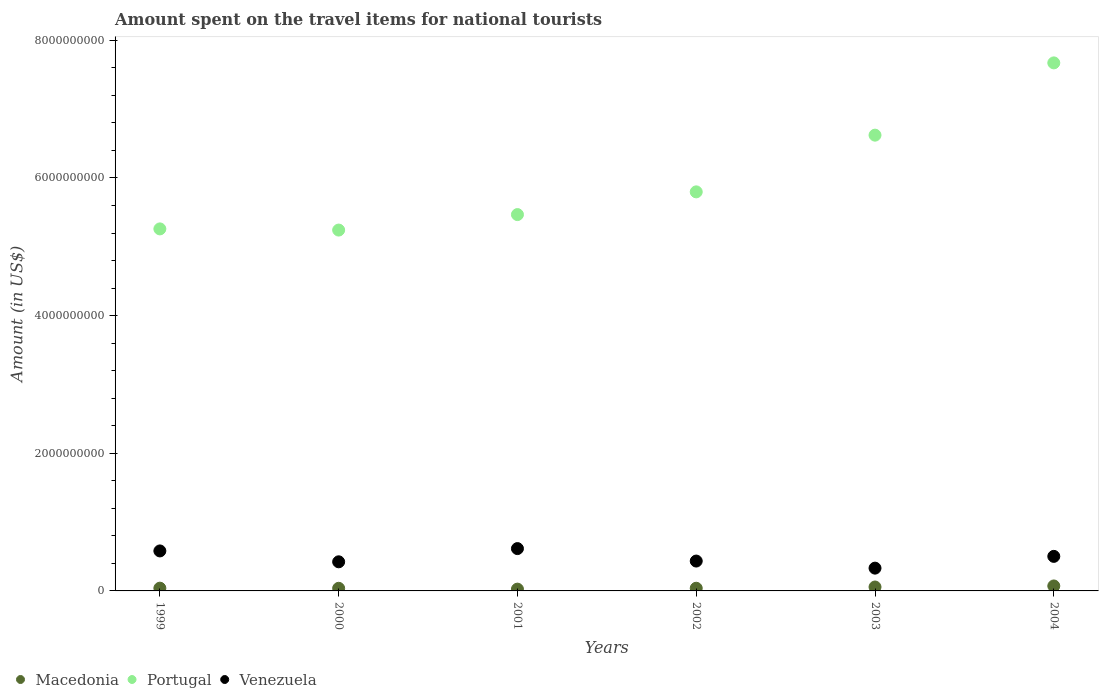How many different coloured dotlines are there?
Offer a very short reply. 3. What is the amount spent on the travel items for national tourists in Portugal in 2004?
Your answer should be very brief. 7.67e+09. Across all years, what is the maximum amount spent on the travel items for national tourists in Portugal?
Offer a terse response. 7.67e+09. Across all years, what is the minimum amount spent on the travel items for national tourists in Macedonia?
Your response must be concise. 2.60e+07. In which year was the amount spent on the travel items for national tourists in Venezuela minimum?
Your answer should be very brief. 2003. What is the total amount spent on the travel items for national tourists in Macedonia in the graph?
Make the answer very short. 2.72e+08. What is the difference between the amount spent on the travel items for national tourists in Macedonia in 2001 and that in 2004?
Give a very brief answer. -4.60e+07. What is the difference between the amount spent on the travel items for national tourists in Macedonia in 2001 and the amount spent on the travel items for national tourists in Venezuela in 2000?
Offer a very short reply. -3.97e+08. What is the average amount spent on the travel items for national tourists in Portugal per year?
Make the answer very short. 6.01e+09. In the year 2004, what is the difference between the amount spent on the travel items for national tourists in Venezuela and amount spent on the travel items for national tourists in Portugal?
Give a very brief answer. -7.17e+09. What is the ratio of the amount spent on the travel items for national tourists in Macedonia in 1999 to that in 2002?
Your answer should be very brief. 1.03. Is the difference between the amount spent on the travel items for national tourists in Venezuela in 2000 and 2004 greater than the difference between the amount spent on the travel items for national tourists in Portugal in 2000 and 2004?
Offer a terse response. Yes. What is the difference between the highest and the second highest amount spent on the travel items for national tourists in Macedonia?
Provide a succinct answer. 1.50e+07. What is the difference between the highest and the lowest amount spent on the travel items for national tourists in Portugal?
Give a very brief answer. 2.43e+09. Does the amount spent on the travel items for national tourists in Macedonia monotonically increase over the years?
Offer a very short reply. No. Is the amount spent on the travel items for national tourists in Macedonia strictly greater than the amount spent on the travel items for national tourists in Portugal over the years?
Keep it short and to the point. No. Is the amount spent on the travel items for national tourists in Venezuela strictly less than the amount spent on the travel items for national tourists in Portugal over the years?
Your response must be concise. Yes. What is the difference between two consecutive major ticks on the Y-axis?
Ensure brevity in your answer.  2.00e+09. Are the values on the major ticks of Y-axis written in scientific E-notation?
Give a very brief answer. No. Does the graph contain any zero values?
Your answer should be very brief. No. Where does the legend appear in the graph?
Your answer should be compact. Bottom left. How many legend labels are there?
Ensure brevity in your answer.  3. How are the legend labels stacked?
Ensure brevity in your answer.  Horizontal. What is the title of the graph?
Your answer should be very brief. Amount spent on the travel items for national tourists. Does "Papua New Guinea" appear as one of the legend labels in the graph?
Offer a very short reply. No. What is the label or title of the X-axis?
Your answer should be very brief. Years. What is the label or title of the Y-axis?
Your answer should be compact. Amount (in US$). What is the Amount (in US$) in Macedonia in 1999?
Provide a short and direct response. 4.00e+07. What is the Amount (in US$) of Portugal in 1999?
Keep it short and to the point. 5.26e+09. What is the Amount (in US$) of Venezuela in 1999?
Give a very brief answer. 5.81e+08. What is the Amount (in US$) of Macedonia in 2000?
Your answer should be compact. 3.80e+07. What is the Amount (in US$) in Portugal in 2000?
Ensure brevity in your answer.  5.24e+09. What is the Amount (in US$) of Venezuela in 2000?
Provide a succinct answer. 4.23e+08. What is the Amount (in US$) of Macedonia in 2001?
Your answer should be compact. 2.60e+07. What is the Amount (in US$) in Portugal in 2001?
Offer a very short reply. 5.47e+09. What is the Amount (in US$) in Venezuela in 2001?
Offer a terse response. 6.15e+08. What is the Amount (in US$) of Macedonia in 2002?
Provide a succinct answer. 3.90e+07. What is the Amount (in US$) of Portugal in 2002?
Your answer should be very brief. 5.80e+09. What is the Amount (in US$) of Venezuela in 2002?
Ensure brevity in your answer.  4.34e+08. What is the Amount (in US$) in Macedonia in 2003?
Provide a short and direct response. 5.70e+07. What is the Amount (in US$) of Portugal in 2003?
Your answer should be very brief. 6.62e+09. What is the Amount (in US$) in Venezuela in 2003?
Ensure brevity in your answer.  3.31e+08. What is the Amount (in US$) of Macedonia in 2004?
Offer a very short reply. 7.20e+07. What is the Amount (in US$) in Portugal in 2004?
Your response must be concise. 7.67e+09. What is the Amount (in US$) in Venezuela in 2004?
Give a very brief answer. 5.02e+08. Across all years, what is the maximum Amount (in US$) of Macedonia?
Offer a terse response. 7.20e+07. Across all years, what is the maximum Amount (in US$) of Portugal?
Your answer should be very brief. 7.67e+09. Across all years, what is the maximum Amount (in US$) in Venezuela?
Your response must be concise. 6.15e+08. Across all years, what is the minimum Amount (in US$) of Macedonia?
Your response must be concise. 2.60e+07. Across all years, what is the minimum Amount (in US$) of Portugal?
Provide a short and direct response. 5.24e+09. Across all years, what is the minimum Amount (in US$) in Venezuela?
Make the answer very short. 3.31e+08. What is the total Amount (in US$) of Macedonia in the graph?
Your response must be concise. 2.72e+08. What is the total Amount (in US$) of Portugal in the graph?
Provide a short and direct response. 3.61e+1. What is the total Amount (in US$) of Venezuela in the graph?
Offer a very short reply. 2.89e+09. What is the difference between the Amount (in US$) of Macedonia in 1999 and that in 2000?
Your answer should be compact. 2.00e+06. What is the difference between the Amount (in US$) of Portugal in 1999 and that in 2000?
Give a very brief answer. 1.70e+07. What is the difference between the Amount (in US$) of Venezuela in 1999 and that in 2000?
Ensure brevity in your answer.  1.58e+08. What is the difference between the Amount (in US$) in Macedonia in 1999 and that in 2001?
Make the answer very short. 1.40e+07. What is the difference between the Amount (in US$) in Portugal in 1999 and that in 2001?
Give a very brief answer. -2.08e+08. What is the difference between the Amount (in US$) of Venezuela in 1999 and that in 2001?
Your answer should be very brief. -3.40e+07. What is the difference between the Amount (in US$) in Macedonia in 1999 and that in 2002?
Provide a succinct answer. 1.00e+06. What is the difference between the Amount (in US$) in Portugal in 1999 and that in 2002?
Give a very brief answer. -5.38e+08. What is the difference between the Amount (in US$) of Venezuela in 1999 and that in 2002?
Ensure brevity in your answer.  1.47e+08. What is the difference between the Amount (in US$) in Macedonia in 1999 and that in 2003?
Make the answer very short. -1.70e+07. What is the difference between the Amount (in US$) of Portugal in 1999 and that in 2003?
Provide a short and direct response. -1.36e+09. What is the difference between the Amount (in US$) in Venezuela in 1999 and that in 2003?
Your response must be concise. 2.50e+08. What is the difference between the Amount (in US$) of Macedonia in 1999 and that in 2004?
Provide a succinct answer. -3.20e+07. What is the difference between the Amount (in US$) in Portugal in 1999 and that in 2004?
Provide a succinct answer. -2.41e+09. What is the difference between the Amount (in US$) of Venezuela in 1999 and that in 2004?
Make the answer very short. 7.90e+07. What is the difference between the Amount (in US$) in Portugal in 2000 and that in 2001?
Keep it short and to the point. -2.25e+08. What is the difference between the Amount (in US$) in Venezuela in 2000 and that in 2001?
Give a very brief answer. -1.92e+08. What is the difference between the Amount (in US$) in Macedonia in 2000 and that in 2002?
Offer a terse response. -1.00e+06. What is the difference between the Amount (in US$) in Portugal in 2000 and that in 2002?
Provide a succinct answer. -5.55e+08. What is the difference between the Amount (in US$) in Venezuela in 2000 and that in 2002?
Offer a very short reply. -1.10e+07. What is the difference between the Amount (in US$) of Macedonia in 2000 and that in 2003?
Make the answer very short. -1.90e+07. What is the difference between the Amount (in US$) in Portugal in 2000 and that in 2003?
Offer a very short reply. -1.38e+09. What is the difference between the Amount (in US$) of Venezuela in 2000 and that in 2003?
Offer a terse response. 9.20e+07. What is the difference between the Amount (in US$) in Macedonia in 2000 and that in 2004?
Your answer should be very brief. -3.40e+07. What is the difference between the Amount (in US$) in Portugal in 2000 and that in 2004?
Your answer should be compact. -2.43e+09. What is the difference between the Amount (in US$) of Venezuela in 2000 and that in 2004?
Your answer should be compact. -7.90e+07. What is the difference between the Amount (in US$) of Macedonia in 2001 and that in 2002?
Make the answer very short. -1.30e+07. What is the difference between the Amount (in US$) of Portugal in 2001 and that in 2002?
Make the answer very short. -3.30e+08. What is the difference between the Amount (in US$) in Venezuela in 2001 and that in 2002?
Offer a terse response. 1.81e+08. What is the difference between the Amount (in US$) of Macedonia in 2001 and that in 2003?
Ensure brevity in your answer.  -3.10e+07. What is the difference between the Amount (in US$) in Portugal in 2001 and that in 2003?
Provide a succinct answer. -1.15e+09. What is the difference between the Amount (in US$) in Venezuela in 2001 and that in 2003?
Your answer should be very brief. 2.84e+08. What is the difference between the Amount (in US$) in Macedonia in 2001 and that in 2004?
Make the answer very short. -4.60e+07. What is the difference between the Amount (in US$) in Portugal in 2001 and that in 2004?
Offer a very short reply. -2.20e+09. What is the difference between the Amount (in US$) in Venezuela in 2001 and that in 2004?
Your answer should be compact. 1.13e+08. What is the difference between the Amount (in US$) of Macedonia in 2002 and that in 2003?
Your answer should be compact. -1.80e+07. What is the difference between the Amount (in US$) in Portugal in 2002 and that in 2003?
Make the answer very short. -8.24e+08. What is the difference between the Amount (in US$) in Venezuela in 2002 and that in 2003?
Give a very brief answer. 1.03e+08. What is the difference between the Amount (in US$) of Macedonia in 2002 and that in 2004?
Offer a very short reply. -3.30e+07. What is the difference between the Amount (in US$) in Portugal in 2002 and that in 2004?
Keep it short and to the point. -1.87e+09. What is the difference between the Amount (in US$) in Venezuela in 2002 and that in 2004?
Your answer should be compact. -6.80e+07. What is the difference between the Amount (in US$) of Macedonia in 2003 and that in 2004?
Provide a succinct answer. -1.50e+07. What is the difference between the Amount (in US$) in Portugal in 2003 and that in 2004?
Offer a terse response. -1.05e+09. What is the difference between the Amount (in US$) of Venezuela in 2003 and that in 2004?
Your answer should be very brief. -1.71e+08. What is the difference between the Amount (in US$) in Macedonia in 1999 and the Amount (in US$) in Portugal in 2000?
Provide a succinct answer. -5.20e+09. What is the difference between the Amount (in US$) in Macedonia in 1999 and the Amount (in US$) in Venezuela in 2000?
Make the answer very short. -3.83e+08. What is the difference between the Amount (in US$) in Portugal in 1999 and the Amount (in US$) in Venezuela in 2000?
Keep it short and to the point. 4.84e+09. What is the difference between the Amount (in US$) in Macedonia in 1999 and the Amount (in US$) in Portugal in 2001?
Your answer should be very brief. -5.43e+09. What is the difference between the Amount (in US$) in Macedonia in 1999 and the Amount (in US$) in Venezuela in 2001?
Offer a terse response. -5.75e+08. What is the difference between the Amount (in US$) of Portugal in 1999 and the Amount (in US$) of Venezuela in 2001?
Ensure brevity in your answer.  4.64e+09. What is the difference between the Amount (in US$) of Macedonia in 1999 and the Amount (in US$) of Portugal in 2002?
Make the answer very short. -5.76e+09. What is the difference between the Amount (in US$) of Macedonia in 1999 and the Amount (in US$) of Venezuela in 2002?
Provide a short and direct response. -3.94e+08. What is the difference between the Amount (in US$) in Portugal in 1999 and the Amount (in US$) in Venezuela in 2002?
Give a very brief answer. 4.83e+09. What is the difference between the Amount (in US$) of Macedonia in 1999 and the Amount (in US$) of Portugal in 2003?
Offer a terse response. -6.58e+09. What is the difference between the Amount (in US$) of Macedonia in 1999 and the Amount (in US$) of Venezuela in 2003?
Ensure brevity in your answer.  -2.91e+08. What is the difference between the Amount (in US$) of Portugal in 1999 and the Amount (in US$) of Venezuela in 2003?
Your answer should be very brief. 4.93e+09. What is the difference between the Amount (in US$) of Macedonia in 1999 and the Amount (in US$) of Portugal in 2004?
Keep it short and to the point. -7.63e+09. What is the difference between the Amount (in US$) of Macedonia in 1999 and the Amount (in US$) of Venezuela in 2004?
Make the answer very short. -4.62e+08. What is the difference between the Amount (in US$) in Portugal in 1999 and the Amount (in US$) in Venezuela in 2004?
Offer a very short reply. 4.76e+09. What is the difference between the Amount (in US$) of Macedonia in 2000 and the Amount (in US$) of Portugal in 2001?
Offer a very short reply. -5.43e+09. What is the difference between the Amount (in US$) of Macedonia in 2000 and the Amount (in US$) of Venezuela in 2001?
Your answer should be compact. -5.77e+08. What is the difference between the Amount (in US$) in Portugal in 2000 and the Amount (in US$) in Venezuela in 2001?
Offer a very short reply. 4.63e+09. What is the difference between the Amount (in US$) of Macedonia in 2000 and the Amount (in US$) of Portugal in 2002?
Offer a very short reply. -5.76e+09. What is the difference between the Amount (in US$) of Macedonia in 2000 and the Amount (in US$) of Venezuela in 2002?
Ensure brevity in your answer.  -3.96e+08. What is the difference between the Amount (in US$) in Portugal in 2000 and the Amount (in US$) in Venezuela in 2002?
Make the answer very short. 4.81e+09. What is the difference between the Amount (in US$) of Macedonia in 2000 and the Amount (in US$) of Portugal in 2003?
Provide a succinct answer. -6.58e+09. What is the difference between the Amount (in US$) in Macedonia in 2000 and the Amount (in US$) in Venezuela in 2003?
Provide a succinct answer. -2.93e+08. What is the difference between the Amount (in US$) of Portugal in 2000 and the Amount (in US$) of Venezuela in 2003?
Give a very brief answer. 4.91e+09. What is the difference between the Amount (in US$) of Macedonia in 2000 and the Amount (in US$) of Portugal in 2004?
Offer a very short reply. -7.63e+09. What is the difference between the Amount (in US$) in Macedonia in 2000 and the Amount (in US$) in Venezuela in 2004?
Make the answer very short. -4.64e+08. What is the difference between the Amount (in US$) in Portugal in 2000 and the Amount (in US$) in Venezuela in 2004?
Provide a short and direct response. 4.74e+09. What is the difference between the Amount (in US$) of Macedonia in 2001 and the Amount (in US$) of Portugal in 2002?
Keep it short and to the point. -5.77e+09. What is the difference between the Amount (in US$) in Macedonia in 2001 and the Amount (in US$) in Venezuela in 2002?
Ensure brevity in your answer.  -4.08e+08. What is the difference between the Amount (in US$) of Portugal in 2001 and the Amount (in US$) of Venezuela in 2002?
Your response must be concise. 5.03e+09. What is the difference between the Amount (in US$) in Macedonia in 2001 and the Amount (in US$) in Portugal in 2003?
Keep it short and to the point. -6.60e+09. What is the difference between the Amount (in US$) of Macedonia in 2001 and the Amount (in US$) of Venezuela in 2003?
Offer a terse response. -3.05e+08. What is the difference between the Amount (in US$) in Portugal in 2001 and the Amount (in US$) in Venezuela in 2003?
Your response must be concise. 5.14e+09. What is the difference between the Amount (in US$) of Macedonia in 2001 and the Amount (in US$) of Portugal in 2004?
Keep it short and to the point. -7.65e+09. What is the difference between the Amount (in US$) of Macedonia in 2001 and the Amount (in US$) of Venezuela in 2004?
Make the answer very short. -4.76e+08. What is the difference between the Amount (in US$) in Portugal in 2001 and the Amount (in US$) in Venezuela in 2004?
Keep it short and to the point. 4.97e+09. What is the difference between the Amount (in US$) of Macedonia in 2002 and the Amount (in US$) of Portugal in 2003?
Offer a very short reply. -6.58e+09. What is the difference between the Amount (in US$) in Macedonia in 2002 and the Amount (in US$) in Venezuela in 2003?
Provide a short and direct response. -2.92e+08. What is the difference between the Amount (in US$) in Portugal in 2002 and the Amount (in US$) in Venezuela in 2003?
Provide a succinct answer. 5.47e+09. What is the difference between the Amount (in US$) in Macedonia in 2002 and the Amount (in US$) in Portugal in 2004?
Your answer should be very brief. -7.63e+09. What is the difference between the Amount (in US$) in Macedonia in 2002 and the Amount (in US$) in Venezuela in 2004?
Make the answer very short. -4.63e+08. What is the difference between the Amount (in US$) in Portugal in 2002 and the Amount (in US$) in Venezuela in 2004?
Provide a short and direct response. 5.30e+09. What is the difference between the Amount (in US$) of Macedonia in 2003 and the Amount (in US$) of Portugal in 2004?
Provide a succinct answer. -7.62e+09. What is the difference between the Amount (in US$) in Macedonia in 2003 and the Amount (in US$) in Venezuela in 2004?
Keep it short and to the point. -4.45e+08. What is the difference between the Amount (in US$) of Portugal in 2003 and the Amount (in US$) of Venezuela in 2004?
Keep it short and to the point. 6.12e+09. What is the average Amount (in US$) in Macedonia per year?
Make the answer very short. 4.53e+07. What is the average Amount (in US$) of Portugal per year?
Ensure brevity in your answer.  6.01e+09. What is the average Amount (in US$) of Venezuela per year?
Provide a short and direct response. 4.81e+08. In the year 1999, what is the difference between the Amount (in US$) in Macedonia and Amount (in US$) in Portugal?
Keep it short and to the point. -5.22e+09. In the year 1999, what is the difference between the Amount (in US$) of Macedonia and Amount (in US$) of Venezuela?
Your answer should be compact. -5.41e+08. In the year 1999, what is the difference between the Amount (in US$) of Portugal and Amount (in US$) of Venezuela?
Provide a succinct answer. 4.68e+09. In the year 2000, what is the difference between the Amount (in US$) of Macedonia and Amount (in US$) of Portugal?
Your answer should be very brief. -5.20e+09. In the year 2000, what is the difference between the Amount (in US$) of Macedonia and Amount (in US$) of Venezuela?
Offer a very short reply. -3.85e+08. In the year 2000, what is the difference between the Amount (in US$) in Portugal and Amount (in US$) in Venezuela?
Provide a succinct answer. 4.82e+09. In the year 2001, what is the difference between the Amount (in US$) in Macedonia and Amount (in US$) in Portugal?
Make the answer very short. -5.44e+09. In the year 2001, what is the difference between the Amount (in US$) in Macedonia and Amount (in US$) in Venezuela?
Your answer should be compact. -5.89e+08. In the year 2001, what is the difference between the Amount (in US$) in Portugal and Amount (in US$) in Venezuela?
Your answer should be compact. 4.85e+09. In the year 2002, what is the difference between the Amount (in US$) of Macedonia and Amount (in US$) of Portugal?
Offer a very short reply. -5.76e+09. In the year 2002, what is the difference between the Amount (in US$) of Macedonia and Amount (in US$) of Venezuela?
Your answer should be compact. -3.95e+08. In the year 2002, what is the difference between the Amount (in US$) in Portugal and Amount (in US$) in Venezuela?
Provide a short and direct response. 5.36e+09. In the year 2003, what is the difference between the Amount (in US$) of Macedonia and Amount (in US$) of Portugal?
Ensure brevity in your answer.  -6.56e+09. In the year 2003, what is the difference between the Amount (in US$) of Macedonia and Amount (in US$) of Venezuela?
Offer a very short reply. -2.74e+08. In the year 2003, what is the difference between the Amount (in US$) in Portugal and Amount (in US$) in Venezuela?
Give a very brief answer. 6.29e+09. In the year 2004, what is the difference between the Amount (in US$) in Macedonia and Amount (in US$) in Portugal?
Your answer should be very brief. -7.60e+09. In the year 2004, what is the difference between the Amount (in US$) of Macedonia and Amount (in US$) of Venezuela?
Offer a terse response. -4.30e+08. In the year 2004, what is the difference between the Amount (in US$) of Portugal and Amount (in US$) of Venezuela?
Provide a succinct answer. 7.17e+09. What is the ratio of the Amount (in US$) of Macedonia in 1999 to that in 2000?
Offer a terse response. 1.05. What is the ratio of the Amount (in US$) of Portugal in 1999 to that in 2000?
Your answer should be compact. 1. What is the ratio of the Amount (in US$) of Venezuela in 1999 to that in 2000?
Ensure brevity in your answer.  1.37. What is the ratio of the Amount (in US$) in Macedonia in 1999 to that in 2001?
Offer a terse response. 1.54. What is the ratio of the Amount (in US$) of Portugal in 1999 to that in 2001?
Offer a terse response. 0.96. What is the ratio of the Amount (in US$) of Venezuela in 1999 to that in 2001?
Your answer should be very brief. 0.94. What is the ratio of the Amount (in US$) in Macedonia in 1999 to that in 2002?
Keep it short and to the point. 1.03. What is the ratio of the Amount (in US$) of Portugal in 1999 to that in 2002?
Your answer should be very brief. 0.91. What is the ratio of the Amount (in US$) in Venezuela in 1999 to that in 2002?
Keep it short and to the point. 1.34. What is the ratio of the Amount (in US$) of Macedonia in 1999 to that in 2003?
Ensure brevity in your answer.  0.7. What is the ratio of the Amount (in US$) of Portugal in 1999 to that in 2003?
Your response must be concise. 0.79. What is the ratio of the Amount (in US$) of Venezuela in 1999 to that in 2003?
Offer a very short reply. 1.76. What is the ratio of the Amount (in US$) in Macedonia in 1999 to that in 2004?
Your response must be concise. 0.56. What is the ratio of the Amount (in US$) of Portugal in 1999 to that in 2004?
Give a very brief answer. 0.69. What is the ratio of the Amount (in US$) of Venezuela in 1999 to that in 2004?
Your response must be concise. 1.16. What is the ratio of the Amount (in US$) in Macedonia in 2000 to that in 2001?
Provide a short and direct response. 1.46. What is the ratio of the Amount (in US$) of Portugal in 2000 to that in 2001?
Offer a terse response. 0.96. What is the ratio of the Amount (in US$) in Venezuela in 2000 to that in 2001?
Ensure brevity in your answer.  0.69. What is the ratio of the Amount (in US$) of Macedonia in 2000 to that in 2002?
Ensure brevity in your answer.  0.97. What is the ratio of the Amount (in US$) in Portugal in 2000 to that in 2002?
Provide a short and direct response. 0.9. What is the ratio of the Amount (in US$) of Venezuela in 2000 to that in 2002?
Your answer should be very brief. 0.97. What is the ratio of the Amount (in US$) of Macedonia in 2000 to that in 2003?
Offer a terse response. 0.67. What is the ratio of the Amount (in US$) of Portugal in 2000 to that in 2003?
Keep it short and to the point. 0.79. What is the ratio of the Amount (in US$) of Venezuela in 2000 to that in 2003?
Offer a very short reply. 1.28. What is the ratio of the Amount (in US$) in Macedonia in 2000 to that in 2004?
Ensure brevity in your answer.  0.53. What is the ratio of the Amount (in US$) of Portugal in 2000 to that in 2004?
Give a very brief answer. 0.68. What is the ratio of the Amount (in US$) of Venezuela in 2000 to that in 2004?
Your response must be concise. 0.84. What is the ratio of the Amount (in US$) in Portugal in 2001 to that in 2002?
Provide a short and direct response. 0.94. What is the ratio of the Amount (in US$) of Venezuela in 2001 to that in 2002?
Ensure brevity in your answer.  1.42. What is the ratio of the Amount (in US$) of Macedonia in 2001 to that in 2003?
Give a very brief answer. 0.46. What is the ratio of the Amount (in US$) in Portugal in 2001 to that in 2003?
Keep it short and to the point. 0.83. What is the ratio of the Amount (in US$) of Venezuela in 2001 to that in 2003?
Your answer should be very brief. 1.86. What is the ratio of the Amount (in US$) in Macedonia in 2001 to that in 2004?
Your answer should be compact. 0.36. What is the ratio of the Amount (in US$) in Portugal in 2001 to that in 2004?
Provide a short and direct response. 0.71. What is the ratio of the Amount (in US$) of Venezuela in 2001 to that in 2004?
Provide a short and direct response. 1.23. What is the ratio of the Amount (in US$) in Macedonia in 2002 to that in 2003?
Make the answer very short. 0.68. What is the ratio of the Amount (in US$) of Portugal in 2002 to that in 2003?
Provide a succinct answer. 0.88. What is the ratio of the Amount (in US$) of Venezuela in 2002 to that in 2003?
Ensure brevity in your answer.  1.31. What is the ratio of the Amount (in US$) in Macedonia in 2002 to that in 2004?
Your answer should be compact. 0.54. What is the ratio of the Amount (in US$) in Portugal in 2002 to that in 2004?
Offer a very short reply. 0.76. What is the ratio of the Amount (in US$) of Venezuela in 2002 to that in 2004?
Your answer should be compact. 0.86. What is the ratio of the Amount (in US$) in Macedonia in 2003 to that in 2004?
Ensure brevity in your answer.  0.79. What is the ratio of the Amount (in US$) of Portugal in 2003 to that in 2004?
Your response must be concise. 0.86. What is the ratio of the Amount (in US$) in Venezuela in 2003 to that in 2004?
Your answer should be very brief. 0.66. What is the difference between the highest and the second highest Amount (in US$) in Macedonia?
Ensure brevity in your answer.  1.50e+07. What is the difference between the highest and the second highest Amount (in US$) in Portugal?
Your answer should be very brief. 1.05e+09. What is the difference between the highest and the second highest Amount (in US$) of Venezuela?
Ensure brevity in your answer.  3.40e+07. What is the difference between the highest and the lowest Amount (in US$) in Macedonia?
Your answer should be very brief. 4.60e+07. What is the difference between the highest and the lowest Amount (in US$) in Portugal?
Provide a short and direct response. 2.43e+09. What is the difference between the highest and the lowest Amount (in US$) in Venezuela?
Offer a terse response. 2.84e+08. 